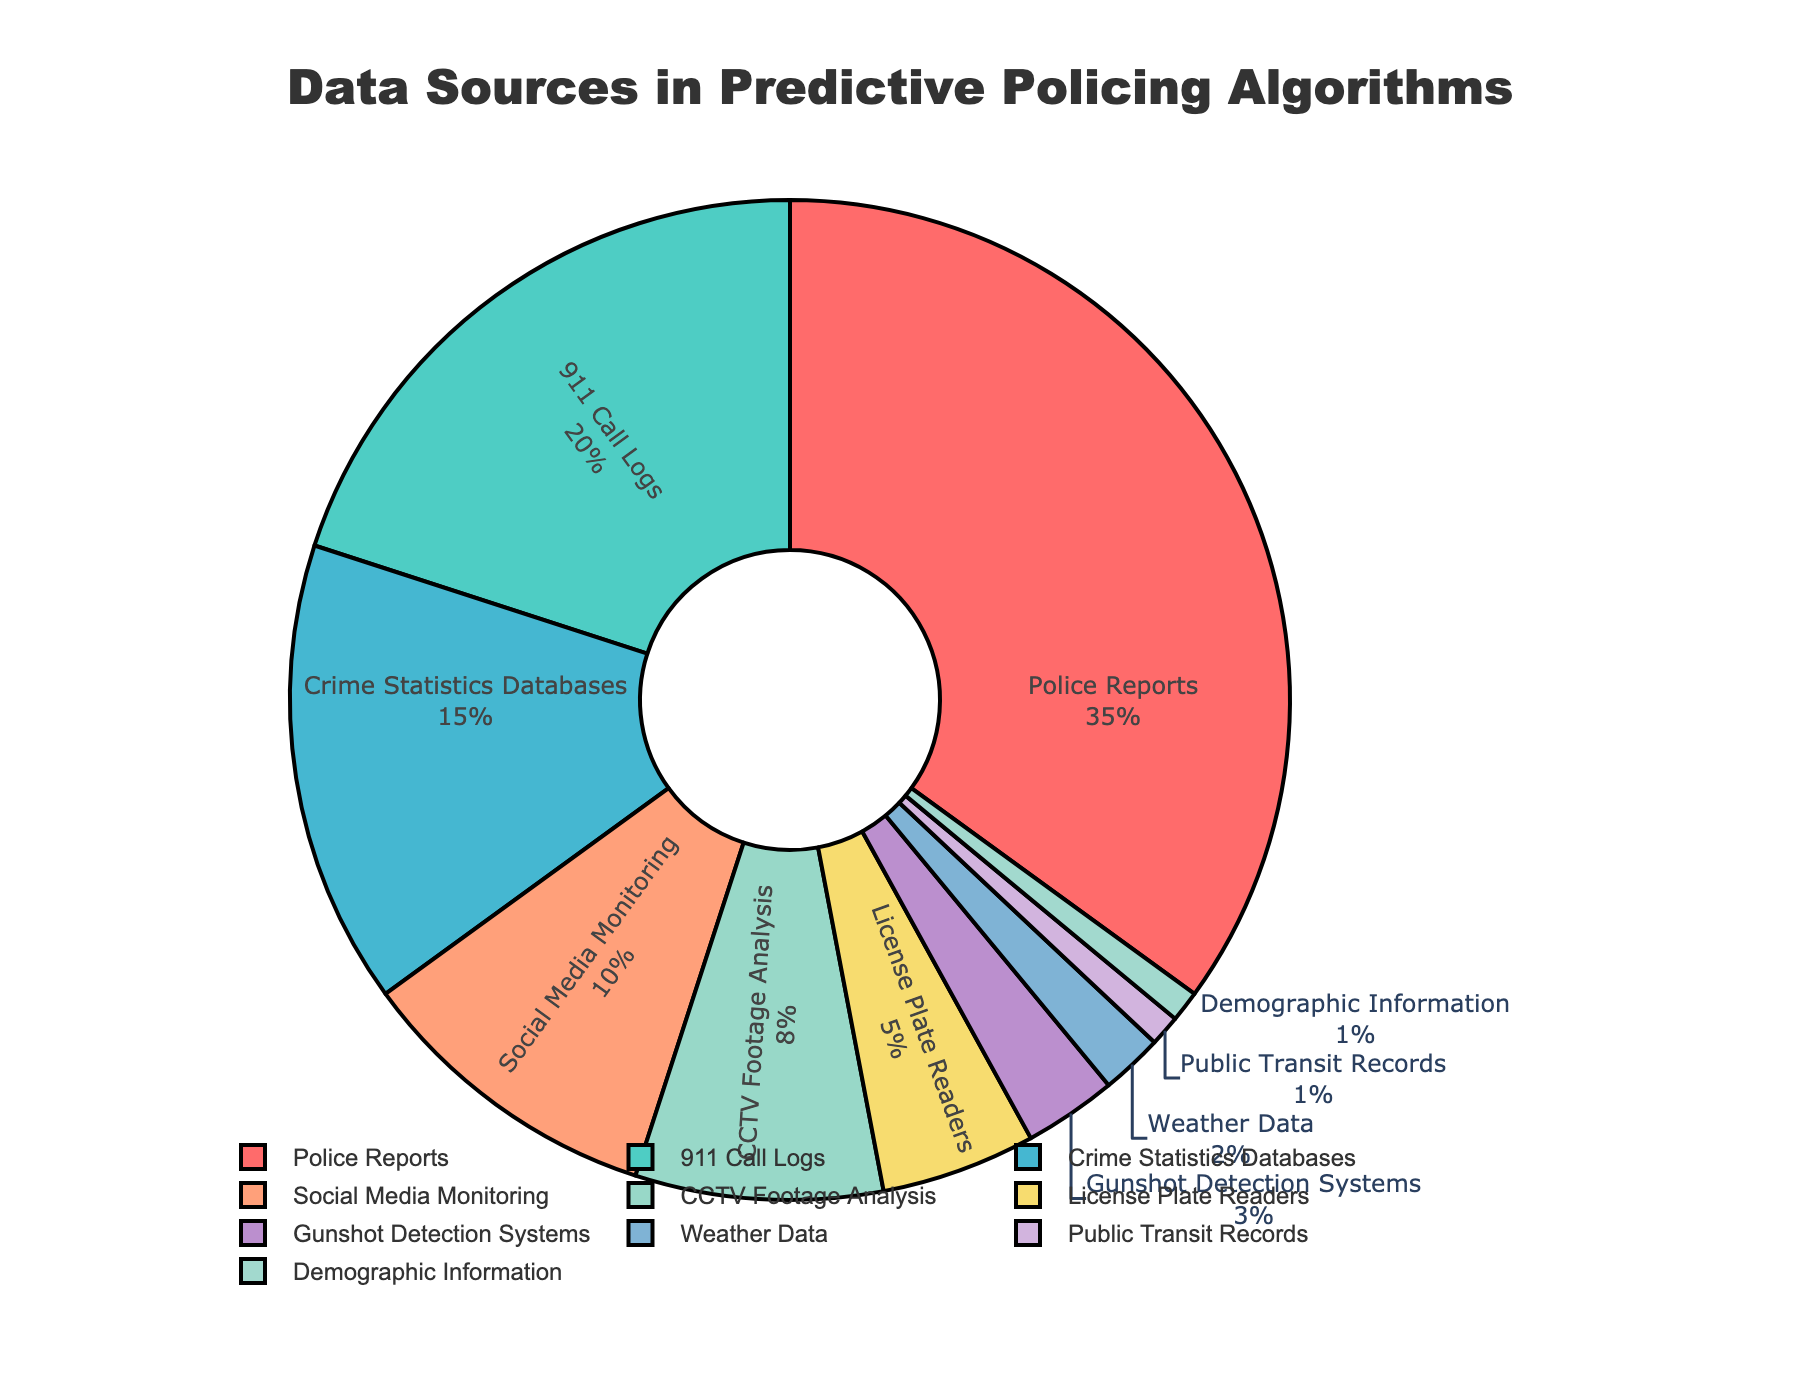What percentage of the data sources used come from Social Media Monitoring and License Plate Readers combined? To find the combined percentage for Social Media Monitoring and License Plate Readers, add their individual percentages: 10% (Social Media Monitoring) + 5% (License Plate Readers) = 15%.
Answer: 15% Which data source contributes the most to the predictive policing algorithms? The data source with the highest percentage is the one that contributes the most. In this case, Police Reports make up 35%, which is the largest percentage.
Answer: Police Reports Is the percentage of 911 Call Logs greater than or less than the combined percentage of CCTV Footage Analysis and Gunshot Detection Systems? First, find the combined percentage of CCTV Footage Analysis and Gunshot Detection Systems: 8% (CCTV Footage Analysis) + 3% (Gunshot Detection Systems) = 11%. Then compare this with the percentage of 911 Call Logs, which is 20%. Since 20% is greater than 11%, the percentage of 911 Call Logs is greater.
Answer: Greater What is the total percentage of data sources that individually contribute less than 5% to the predictive policing algorithms? Identify the data sources contributing less than 5%: Gunshot Detection Systems (3%), Weather Data (2%), Public Transit Records (1%), and Demographic Information (1%). Sum these percentages: 3% + 2% + 1% + 1% = 7%.
Answer: 7% Which data source is represented by the yellow segment in the pie chart? The yellow segment in the pie chart represents the CCTV Footage Analysis data source.
Answer: CCTV Footage Analysis How much larger is the percentage for Police Reports compared to Crime Statistics Databases? Subtract the percentage of Crime Statistics Databases from the percentage of Police Reports: 35% (Police Reports) - 15% (Crime Statistics Databases) = 20%.
Answer: 20% Are there more data sources contributing 10% or more individually or those contributing less than 10%? Count the data sources contributing 10% or more: Police Reports (35%), 911 Call Logs (20%), Crime Statistics Databases (15%), and Social Media Monitoring (10%) = 4 sources. Count the data sources contributing less than 10%: CCTV Footage Analysis (8%), License Plate Readers (5%), Gunshot Detection Systems (3%), Weather Data (2%), Public Transit Records (1%), and Demographic Information (1%) = 6 sources. There are more data sources contributing less than 10%.
Answer: Less than 10% Which data source has the smallest contribution, and what is its percentage? The data sources with the smallest contributions are Public Transit Records and Demographic Information, both at 1%.
Answer: Public Transit Records and Demographic Information (1%) What is the combined percentage of the three largest data sources? The three largest data sources are Police Reports (35%), 911 Call Logs (20%), and Crime Statistics Databases (15%). Their combined percentage is 35% + 20% + 15% = 70%.
Answer: 70% What is the difference in percentage between CCTV Footage Analysis and Social Media Monitoring? Subtract the percentage of CCTV Footage Analysis from Social Media Monitoring: 10% (Social Media Monitoring) - 8% (CCTV Footage Analysis) = 2%.
Answer: 2% 